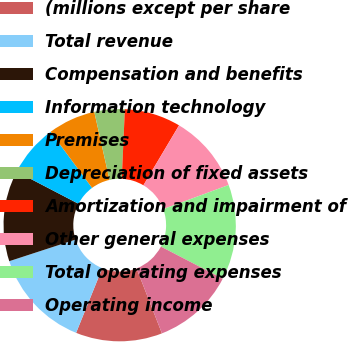<chart> <loc_0><loc_0><loc_500><loc_500><pie_chart><fcel>(millions except per share<fcel>Total revenue<fcel>Compensation and benefits<fcel>Information technology<fcel>Premises<fcel>Depreciation of fixed assets<fcel>Amortization and impairment of<fcel>Other general expenses<fcel>Total operating expenses<fcel>Operating income<nl><fcel>12.05%<fcel>13.86%<fcel>12.65%<fcel>7.23%<fcel>6.63%<fcel>4.22%<fcel>7.83%<fcel>10.84%<fcel>13.25%<fcel>11.45%<nl></chart> 